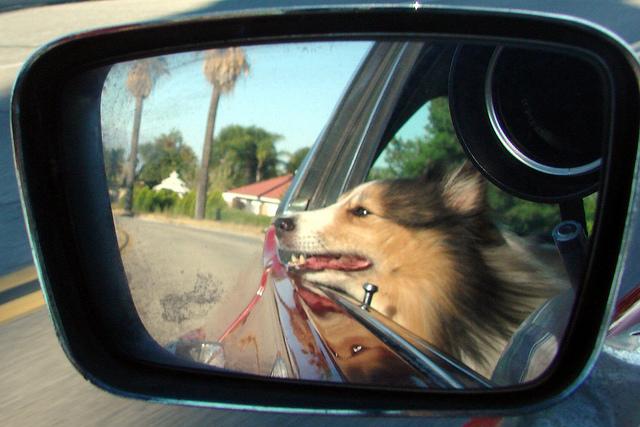Is the car moving?
Write a very short answer. Yes. What is the dog riding in?
Write a very short answer. Car. What is reflecting in the car mirror?
Keep it brief. Dog. 